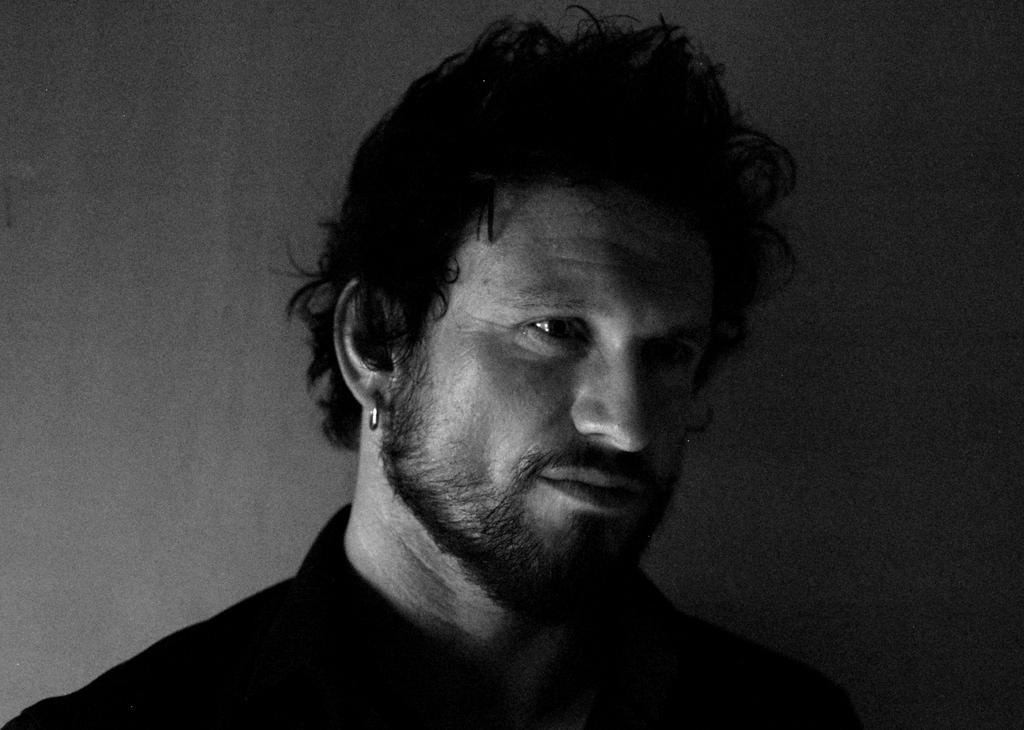Who is present in the image? There is a man in the image. What is the man wearing that is typically associated with women's fashion? The man is wearing earrings. What is the man's focus in the image? The man is looking at something. What can be seen behind the man in the image? There is a wall in the background of the image. What type of plastic object can be seen on the wall in the image? There is no plastic object visible on the wall in the image. 